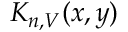<formula> <loc_0><loc_0><loc_500><loc_500>K _ { n , V } ( x , y )</formula> 